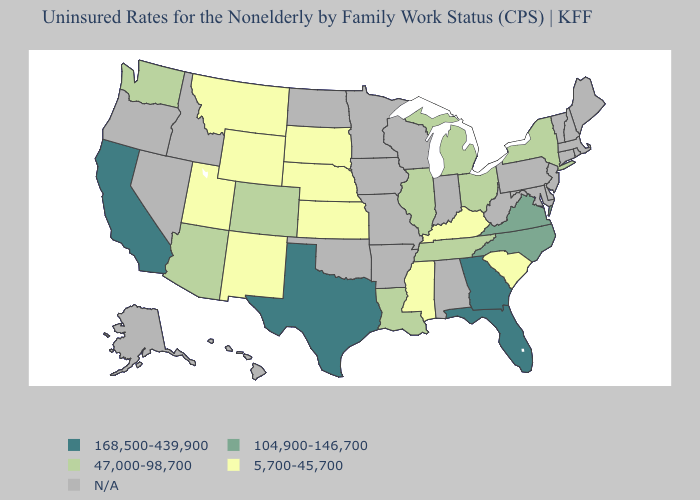What is the value of Kansas?
Give a very brief answer. 5,700-45,700. Name the states that have a value in the range 5,700-45,700?
Quick response, please. Kansas, Kentucky, Mississippi, Montana, Nebraska, New Mexico, South Carolina, South Dakota, Utah, Wyoming. Name the states that have a value in the range 47,000-98,700?
Answer briefly. Arizona, Colorado, Illinois, Louisiana, Michigan, New York, Ohio, Tennessee, Washington. What is the value of Connecticut?
Concise answer only. N/A. Name the states that have a value in the range 168,500-439,900?
Be succinct. California, Florida, Georgia, Texas. What is the lowest value in the Northeast?
Keep it brief. 47,000-98,700. What is the value of Iowa?
Be succinct. N/A. Among the states that border Nevada , does California have the lowest value?
Keep it brief. No. Is the legend a continuous bar?
Quick response, please. No. Does Kansas have the highest value in the MidWest?
Quick response, please. No. What is the highest value in the USA?
Give a very brief answer. 168,500-439,900. Name the states that have a value in the range 104,900-146,700?
Concise answer only. North Carolina, Virginia. What is the lowest value in the South?
Be succinct. 5,700-45,700. 